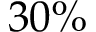Convert formula to latex. <formula><loc_0><loc_0><loc_500><loc_500>3 0 \%</formula> 